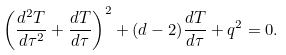<formula> <loc_0><loc_0><loc_500><loc_500>\left ( \frac { d ^ { 2 } T } { d \tau ^ { 2 } } + \frac { d T } { d \tau } \right ) ^ { 2 } + ( d - 2 ) \frac { d T } { d \tau } + q ^ { 2 } = 0 .</formula> 